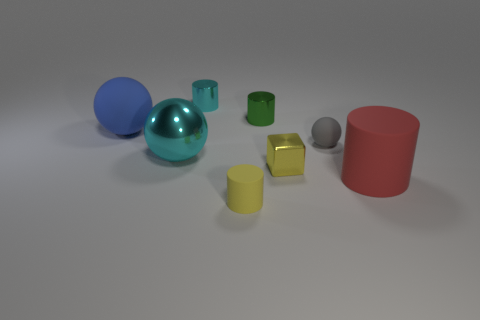Add 1 blue rubber cubes. How many objects exist? 9 Subtract all cubes. How many objects are left? 7 Add 1 green things. How many green things exist? 2 Subtract 0 brown cubes. How many objects are left? 8 Subtract all green cylinders. Subtract all small gray things. How many objects are left? 6 Add 2 cylinders. How many cylinders are left? 6 